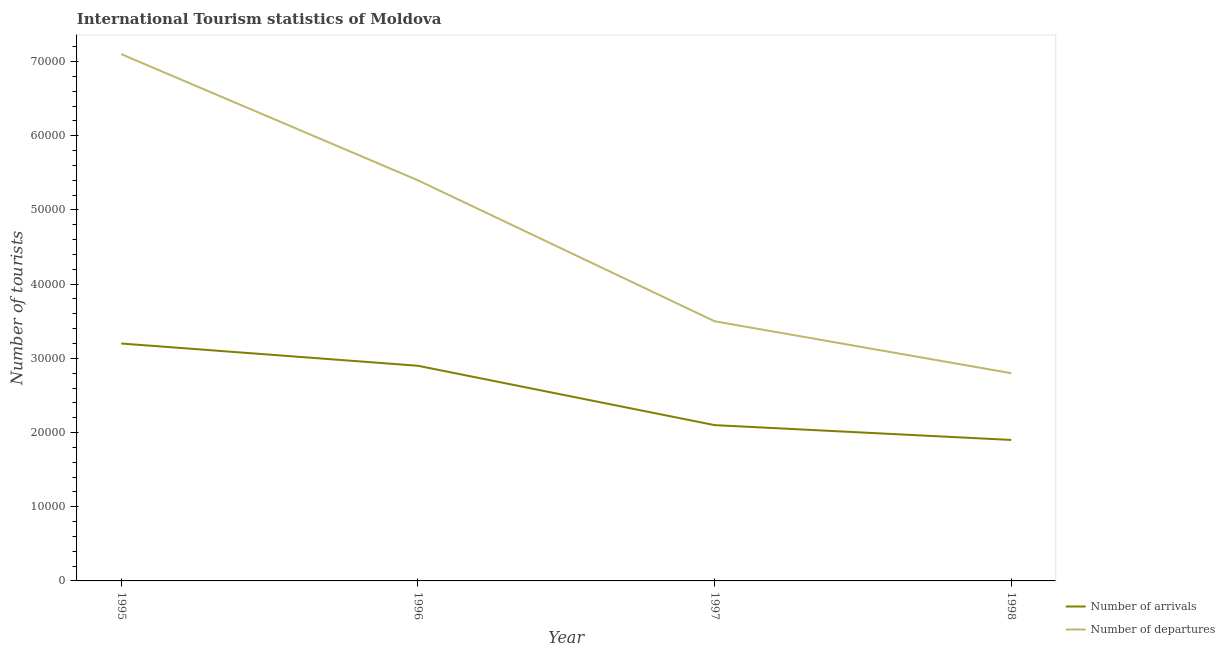How many different coloured lines are there?
Provide a short and direct response. 2. Does the line corresponding to number of tourist departures intersect with the line corresponding to number of tourist arrivals?
Your answer should be compact. No. What is the number of tourist departures in 1996?
Offer a very short reply. 5.40e+04. Across all years, what is the maximum number of tourist arrivals?
Offer a very short reply. 3.20e+04. Across all years, what is the minimum number of tourist arrivals?
Your answer should be very brief. 1.90e+04. What is the total number of tourist departures in the graph?
Your response must be concise. 1.88e+05. What is the difference between the number of tourist departures in 1996 and that in 1998?
Offer a terse response. 2.60e+04. What is the difference between the number of tourist arrivals in 1997 and the number of tourist departures in 1995?
Keep it short and to the point. -5.00e+04. What is the average number of tourist arrivals per year?
Provide a succinct answer. 2.52e+04. In the year 1997, what is the difference between the number of tourist arrivals and number of tourist departures?
Offer a terse response. -1.40e+04. In how many years, is the number of tourist departures greater than 44000?
Make the answer very short. 2. What is the ratio of the number of tourist departures in 1995 to that in 1998?
Offer a terse response. 2.54. Is the difference between the number of tourist departures in 1995 and 1996 greater than the difference between the number of tourist arrivals in 1995 and 1996?
Offer a very short reply. Yes. What is the difference between the highest and the second highest number of tourist departures?
Your answer should be very brief. 1.70e+04. What is the difference between the highest and the lowest number of tourist departures?
Your answer should be compact. 4.30e+04. Is the sum of the number of tourist departures in 1997 and 1998 greater than the maximum number of tourist arrivals across all years?
Offer a terse response. Yes. Is the number of tourist arrivals strictly greater than the number of tourist departures over the years?
Ensure brevity in your answer.  No. Is the number of tourist departures strictly less than the number of tourist arrivals over the years?
Give a very brief answer. No. What is the difference between two consecutive major ticks on the Y-axis?
Your response must be concise. 10000. Are the values on the major ticks of Y-axis written in scientific E-notation?
Keep it short and to the point. No. Does the graph contain grids?
Provide a short and direct response. No. What is the title of the graph?
Your answer should be very brief. International Tourism statistics of Moldova. What is the label or title of the Y-axis?
Make the answer very short. Number of tourists. What is the Number of tourists in Number of arrivals in 1995?
Provide a short and direct response. 3.20e+04. What is the Number of tourists of Number of departures in 1995?
Offer a terse response. 7.10e+04. What is the Number of tourists in Number of arrivals in 1996?
Ensure brevity in your answer.  2.90e+04. What is the Number of tourists in Number of departures in 1996?
Offer a terse response. 5.40e+04. What is the Number of tourists of Number of arrivals in 1997?
Make the answer very short. 2.10e+04. What is the Number of tourists of Number of departures in 1997?
Offer a terse response. 3.50e+04. What is the Number of tourists in Number of arrivals in 1998?
Provide a succinct answer. 1.90e+04. What is the Number of tourists in Number of departures in 1998?
Ensure brevity in your answer.  2.80e+04. Across all years, what is the maximum Number of tourists in Number of arrivals?
Offer a terse response. 3.20e+04. Across all years, what is the maximum Number of tourists in Number of departures?
Your response must be concise. 7.10e+04. Across all years, what is the minimum Number of tourists in Number of arrivals?
Your answer should be very brief. 1.90e+04. Across all years, what is the minimum Number of tourists in Number of departures?
Your response must be concise. 2.80e+04. What is the total Number of tourists of Number of arrivals in the graph?
Your answer should be very brief. 1.01e+05. What is the total Number of tourists of Number of departures in the graph?
Keep it short and to the point. 1.88e+05. What is the difference between the Number of tourists of Number of arrivals in 1995 and that in 1996?
Provide a succinct answer. 3000. What is the difference between the Number of tourists of Number of departures in 1995 and that in 1996?
Your answer should be very brief. 1.70e+04. What is the difference between the Number of tourists of Number of arrivals in 1995 and that in 1997?
Make the answer very short. 1.10e+04. What is the difference between the Number of tourists in Number of departures in 1995 and that in 1997?
Offer a very short reply. 3.60e+04. What is the difference between the Number of tourists of Number of arrivals in 1995 and that in 1998?
Give a very brief answer. 1.30e+04. What is the difference between the Number of tourists in Number of departures in 1995 and that in 1998?
Offer a very short reply. 4.30e+04. What is the difference between the Number of tourists in Number of arrivals in 1996 and that in 1997?
Keep it short and to the point. 8000. What is the difference between the Number of tourists of Number of departures in 1996 and that in 1997?
Your answer should be compact. 1.90e+04. What is the difference between the Number of tourists of Number of departures in 1996 and that in 1998?
Make the answer very short. 2.60e+04. What is the difference between the Number of tourists of Number of departures in 1997 and that in 1998?
Keep it short and to the point. 7000. What is the difference between the Number of tourists of Number of arrivals in 1995 and the Number of tourists of Number of departures in 1996?
Provide a short and direct response. -2.20e+04. What is the difference between the Number of tourists in Number of arrivals in 1995 and the Number of tourists in Number of departures in 1997?
Your answer should be compact. -3000. What is the difference between the Number of tourists of Number of arrivals in 1995 and the Number of tourists of Number of departures in 1998?
Give a very brief answer. 4000. What is the difference between the Number of tourists in Number of arrivals in 1996 and the Number of tourists in Number of departures in 1997?
Provide a short and direct response. -6000. What is the difference between the Number of tourists of Number of arrivals in 1997 and the Number of tourists of Number of departures in 1998?
Keep it short and to the point. -7000. What is the average Number of tourists of Number of arrivals per year?
Make the answer very short. 2.52e+04. What is the average Number of tourists of Number of departures per year?
Your answer should be very brief. 4.70e+04. In the year 1995, what is the difference between the Number of tourists in Number of arrivals and Number of tourists in Number of departures?
Provide a succinct answer. -3.90e+04. In the year 1996, what is the difference between the Number of tourists of Number of arrivals and Number of tourists of Number of departures?
Offer a terse response. -2.50e+04. In the year 1997, what is the difference between the Number of tourists in Number of arrivals and Number of tourists in Number of departures?
Give a very brief answer. -1.40e+04. In the year 1998, what is the difference between the Number of tourists of Number of arrivals and Number of tourists of Number of departures?
Offer a terse response. -9000. What is the ratio of the Number of tourists in Number of arrivals in 1995 to that in 1996?
Offer a very short reply. 1.1. What is the ratio of the Number of tourists in Number of departures in 1995 to that in 1996?
Give a very brief answer. 1.31. What is the ratio of the Number of tourists in Number of arrivals in 1995 to that in 1997?
Ensure brevity in your answer.  1.52. What is the ratio of the Number of tourists of Number of departures in 1995 to that in 1997?
Make the answer very short. 2.03. What is the ratio of the Number of tourists of Number of arrivals in 1995 to that in 1998?
Keep it short and to the point. 1.68. What is the ratio of the Number of tourists of Number of departures in 1995 to that in 1998?
Offer a very short reply. 2.54. What is the ratio of the Number of tourists in Number of arrivals in 1996 to that in 1997?
Make the answer very short. 1.38. What is the ratio of the Number of tourists in Number of departures in 1996 to that in 1997?
Your response must be concise. 1.54. What is the ratio of the Number of tourists in Number of arrivals in 1996 to that in 1998?
Keep it short and to the point. 1.53. What is the ratio of the Number of tourists in Number of departures in 1996 to that in 1998?
Offer a terse response. 1.93. What is the ratio of the Number of tourists in Number of arrivals in 1997 to that in 1998?
Offer a terse response. 1.11. What is the ratio of the Number of tourists in Number of departures in 1997 to that in 1998?
Make the answer very short. 1.25. What is the difference between the highest and the second highest Number of tourists in Number of arrivals?
Offer a terse response. 3000. What is the difference between the highest and the second highest Number of tourists in Number of departures?
Offer a terse response. 1.70e+04. What is the difference between the highest and the lowest Number of tourists in Number of arrivals?
Offer a very short reply. 1.30e+04. What is the difference between the highest and the lowest Number of tourists in Number of departures?
Offer a terse response. 4.30e+04. 